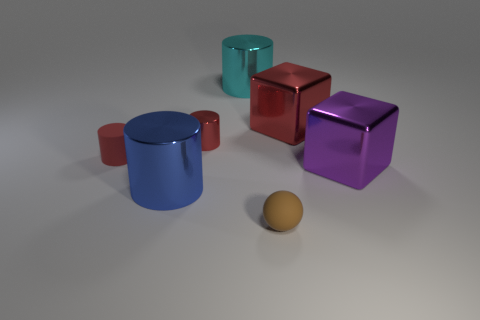There is a red shiny thing that is on the right side of the tiny sphere; is its shape the same as the big cyan metallic object?
Provide a succinct answer. No. There is a purple thing that is in front of the small red shiny cylinder; what is it made of?
Offer a very short reply. Metal. What is the shape of the object that is on the left side of the tiny metal cylinder and behind the blue metal cylinder?
Your answer should be very brief. Cylinder. What material is the big blue object?
Keep it short and to the point. Metal. What number of cylinders are either red rubber objects or small purple things?
Your answer should be compact. 1. Is the big purple object made of the same material as the large cyan object?
Your answer should be very brief. Yes. The other thing that is the same shape as the big purple metallic object is what size?
Your response must be concise. Large. What material is the big object that is both right of the small sphere and on the left side of the large purple object?
Offer a terse response. Metal. Are there an equal number of purple metallic things that are behind the large red metallic thing and rubber cylinders?
Your response must be concise. No. How many things are things to the left of the big cyan shiny object or rubber cylinders?
Ensure brevity in your answer.  3. 